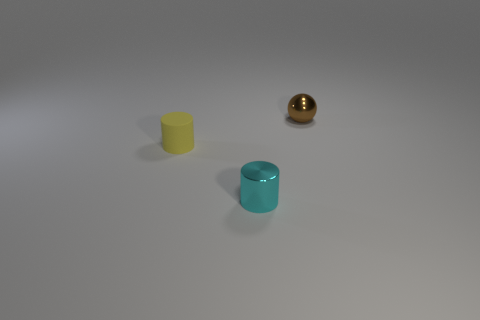Add 2 red rubber cylinders. How many objects exist? 5 Subtract all cylinders. How many objects are left? 1 Subtract all green cylinders. Subtract all cyan spheres. How many cylinders are left? 2 Subtract all red rubber cubes. Subtract all small yellow cylinders. How many objects are left? 2 Add 3 brown spheres. How many brown spheres are left? 4 Add 1 big green metallic spheres. How many big green metallic spheres exist? 1 Subtract 0 cyan balls. How many objects are left? 3 